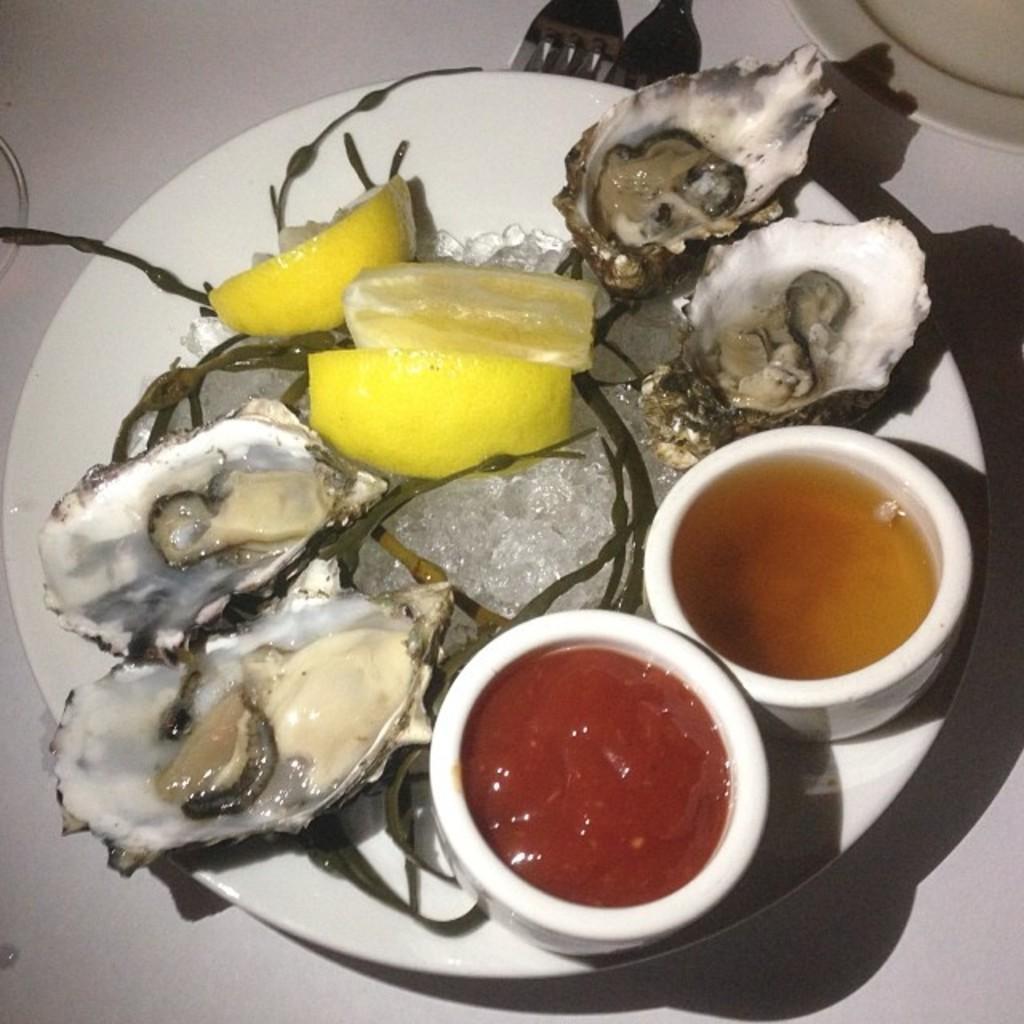Can you describe this image briefly? In this picture we can see a plate, bowls, oysters, forks, and food items on a platform. 